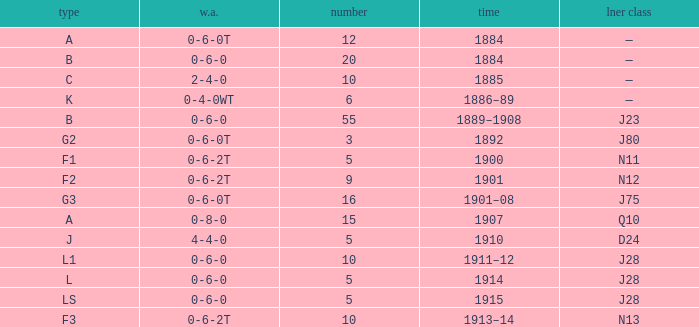What class is associated with a W.A. of 0-8-0? A. 